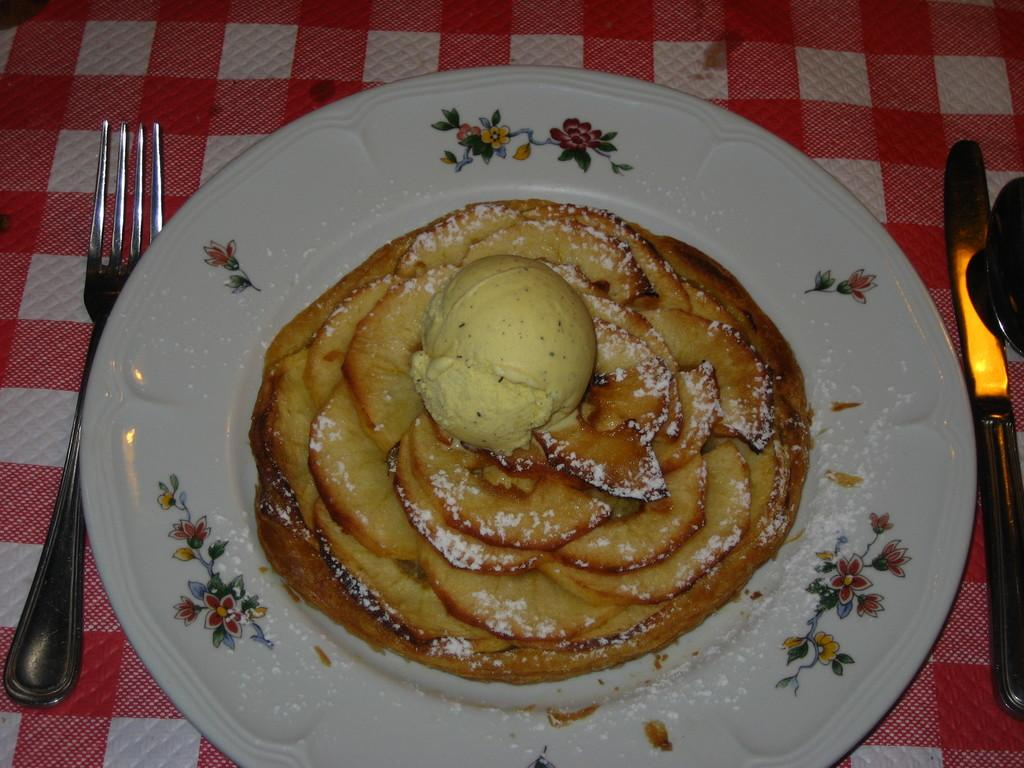What is placed on a surface in the image? There is a plate on a surface in the image. What utensils are near the plate? There is a fork and knife near the plate. Can you describe the plate's appearance? The plate has designs on it. What is on the plate? There is a food item on the plate. What type of pump can be seen in the image? There is no pump present in the image. Is there a lawyer sitting at the table in the image? There is no lawyer or table present in the image. 